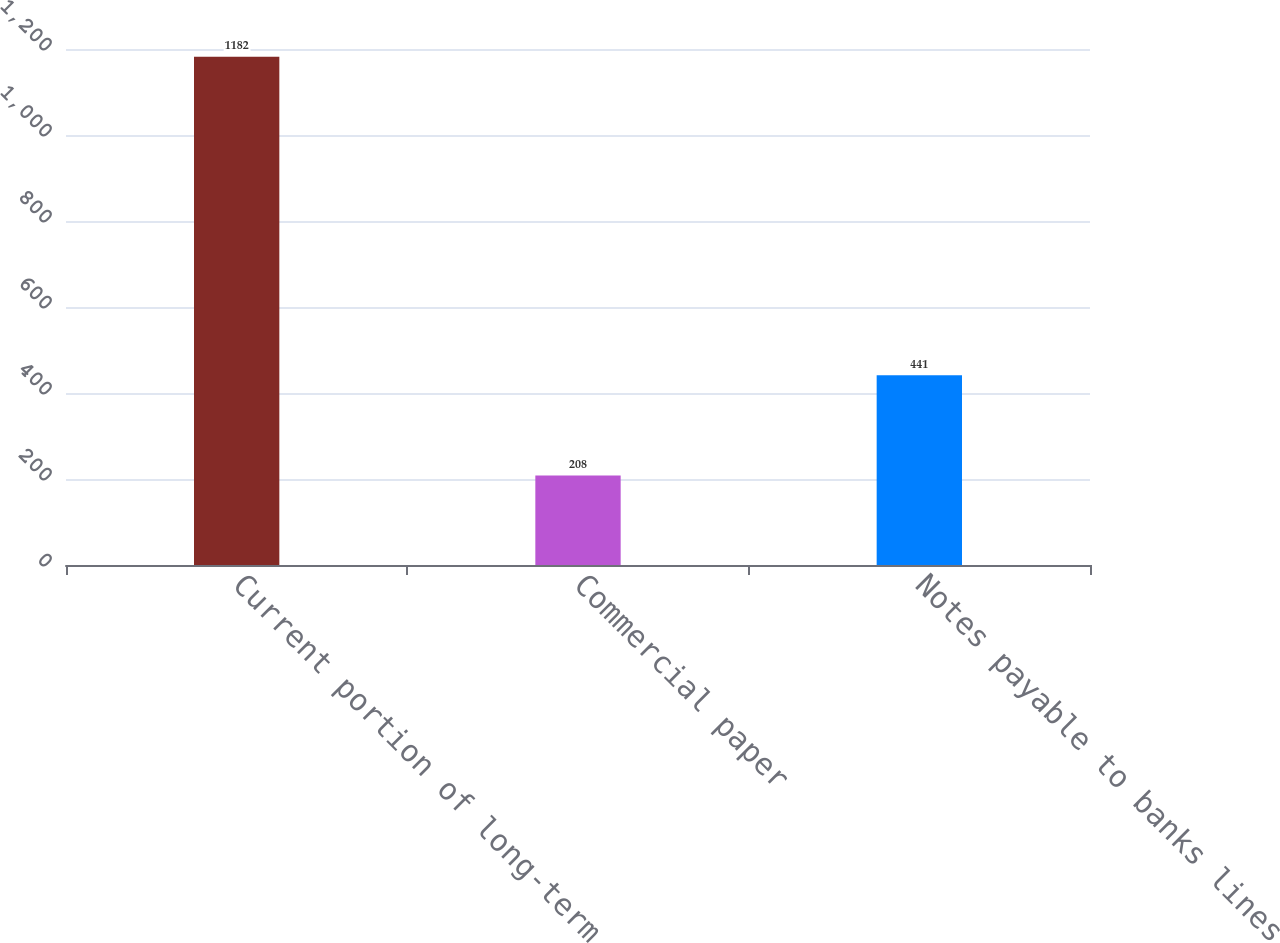<chart> <loc_0><loc_0><loc_500><loc_500><bar_chart><fcel>Current portion of long-term<fcel>Commercial paper<fcel>Notes payable to banks lines<nl><fcel>1182<fcel>208<fcel>441<nl></chart> 